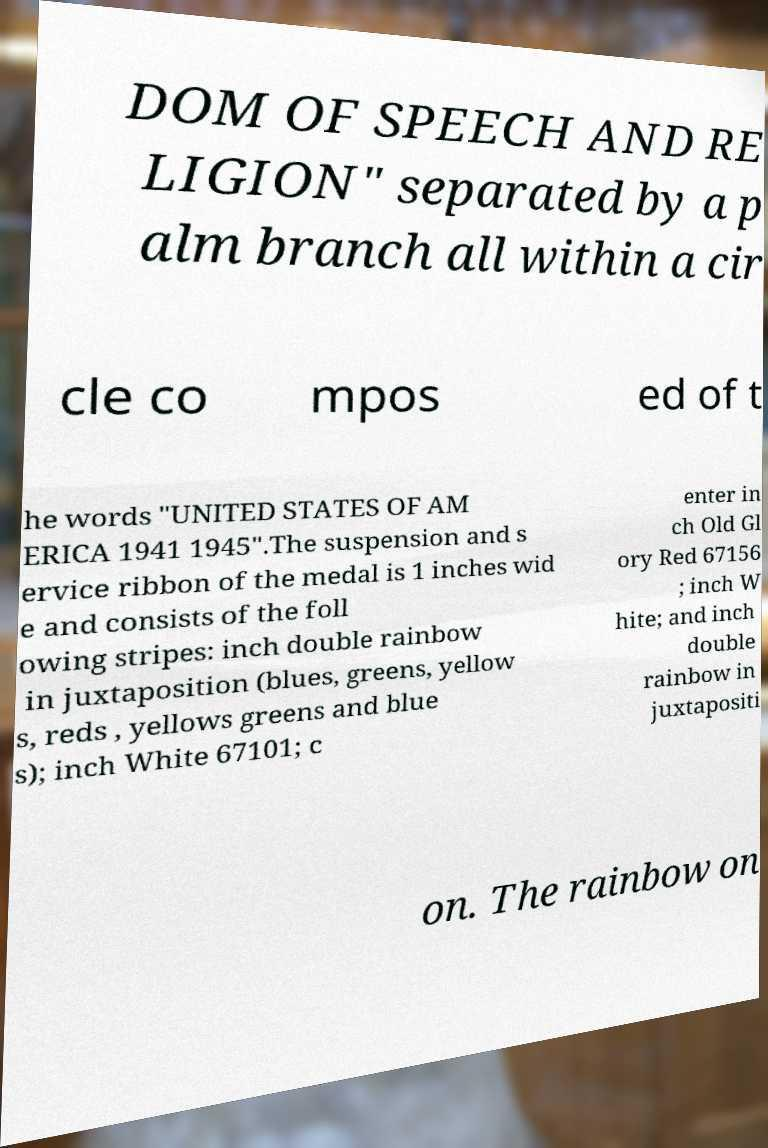There's text embedded in this image that I need extracted. Can you transcribe it verbatim? DOM OF SPEECH AND RE LIGION" separated by a p alm branch all within a cir cle co mpos ed of t he words "UNITED STATES OF AM ERICA 1941 1945".The suspension and s ervice ribbon of the medal is 1 inches wid e and consists of the foll owing stripes: inch double rainbow in juxtaposition (blues, greens, yellow s, reds , yellows greens and blue s); inch White 67101; c enter in ch Old Gl ory Red 67156 ; inch W hite; and inch double rainbow in juxtapositi on. The rainbow on 